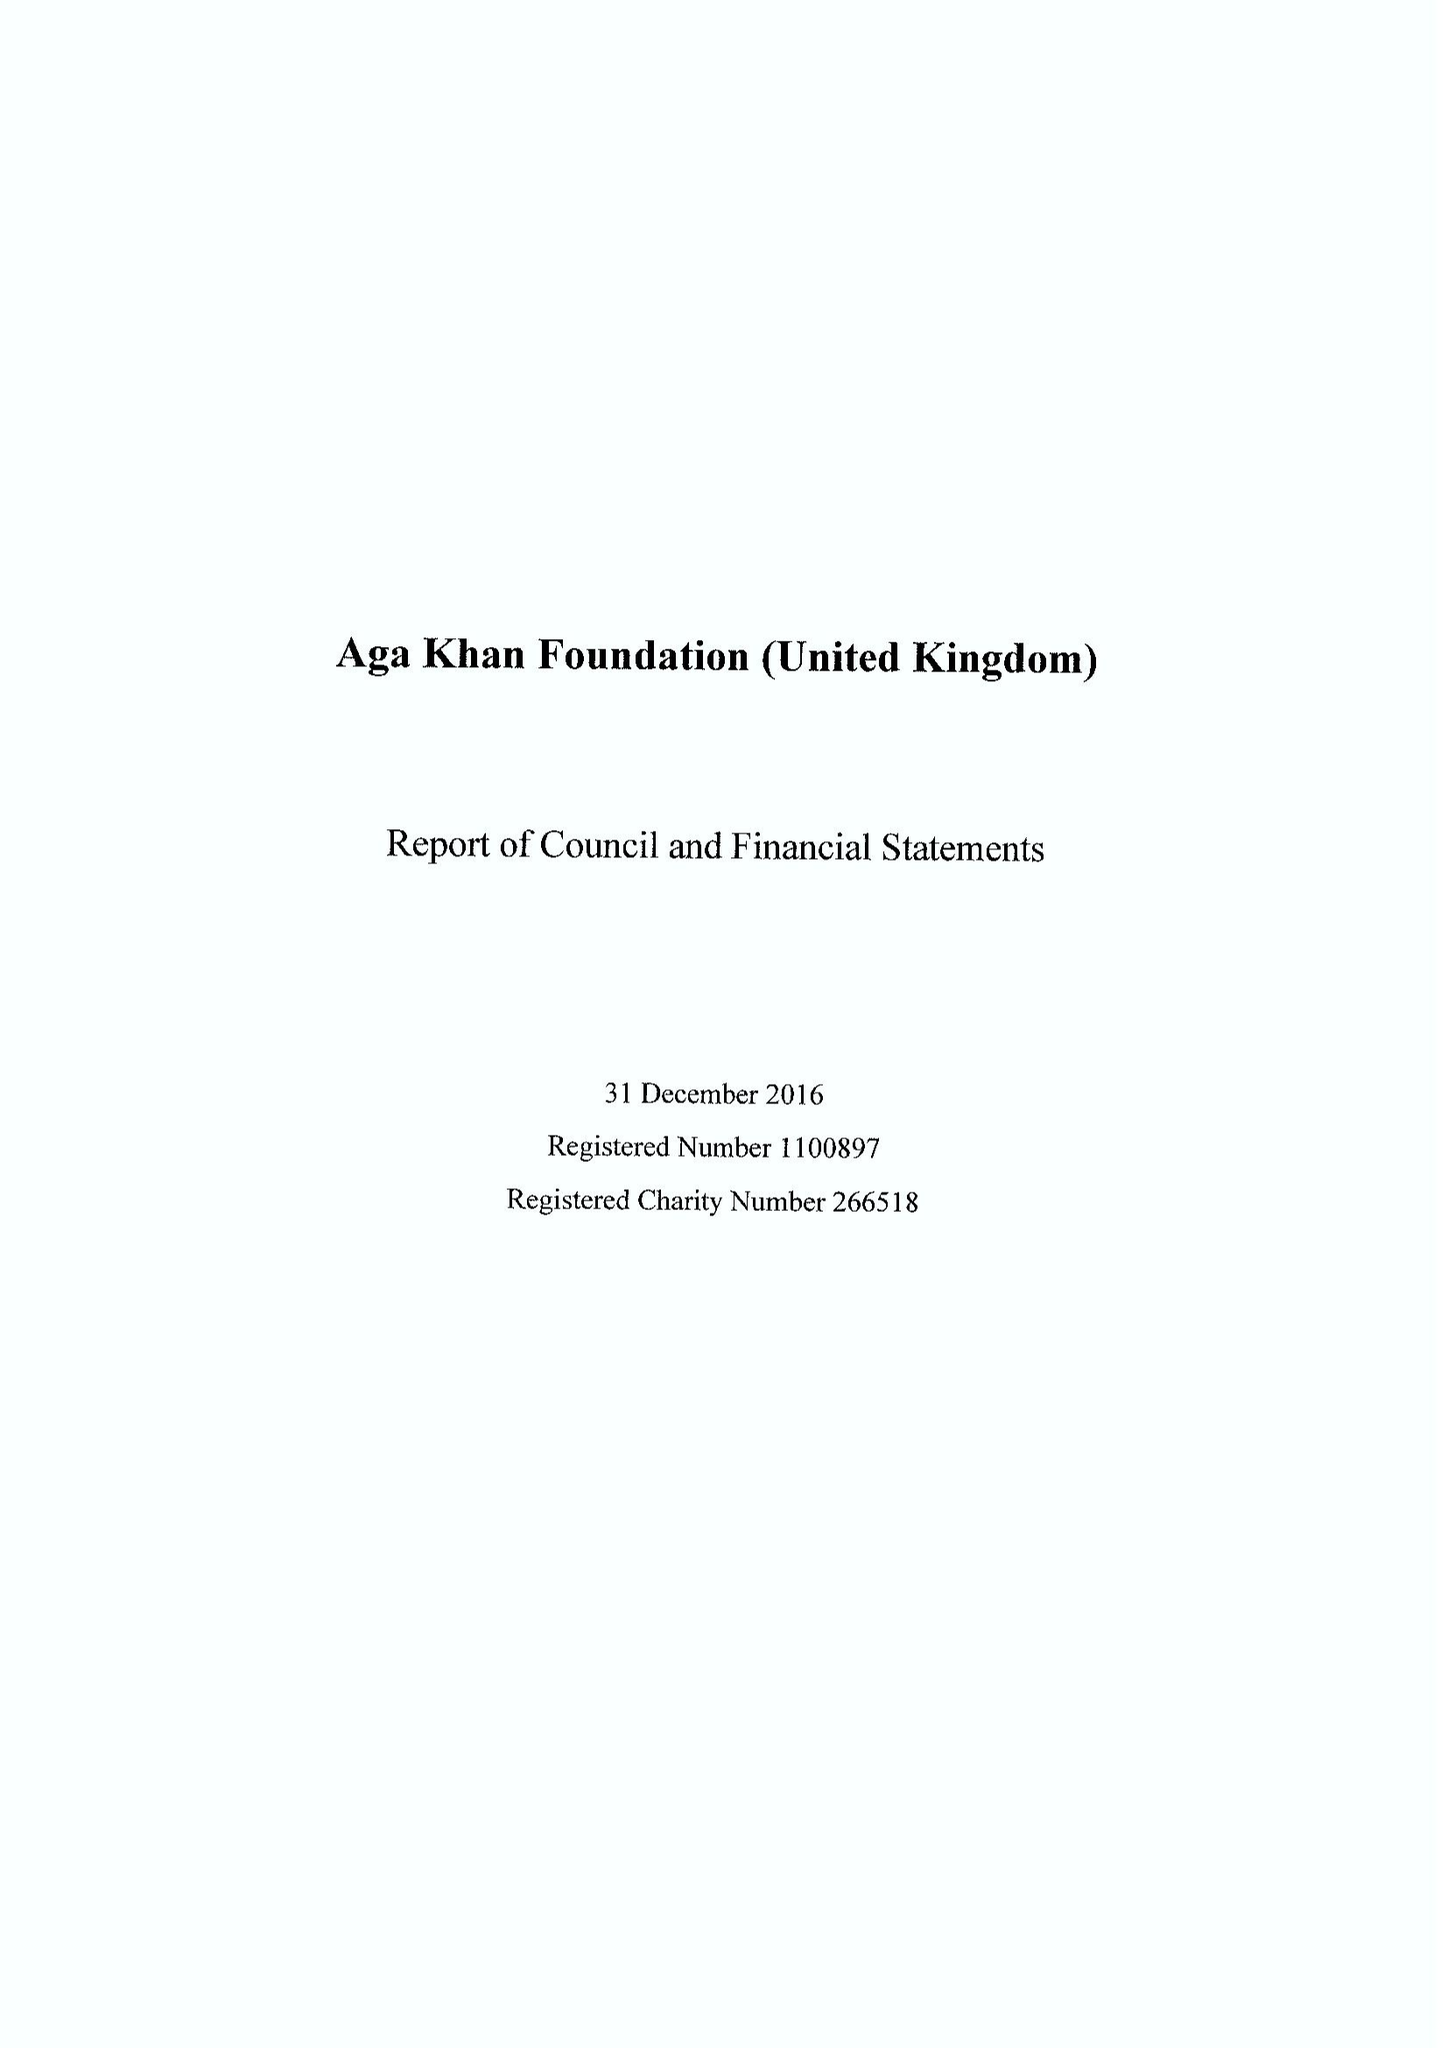What is the value for the charity_number?
Answer the question using a single word or phrase. 266518 